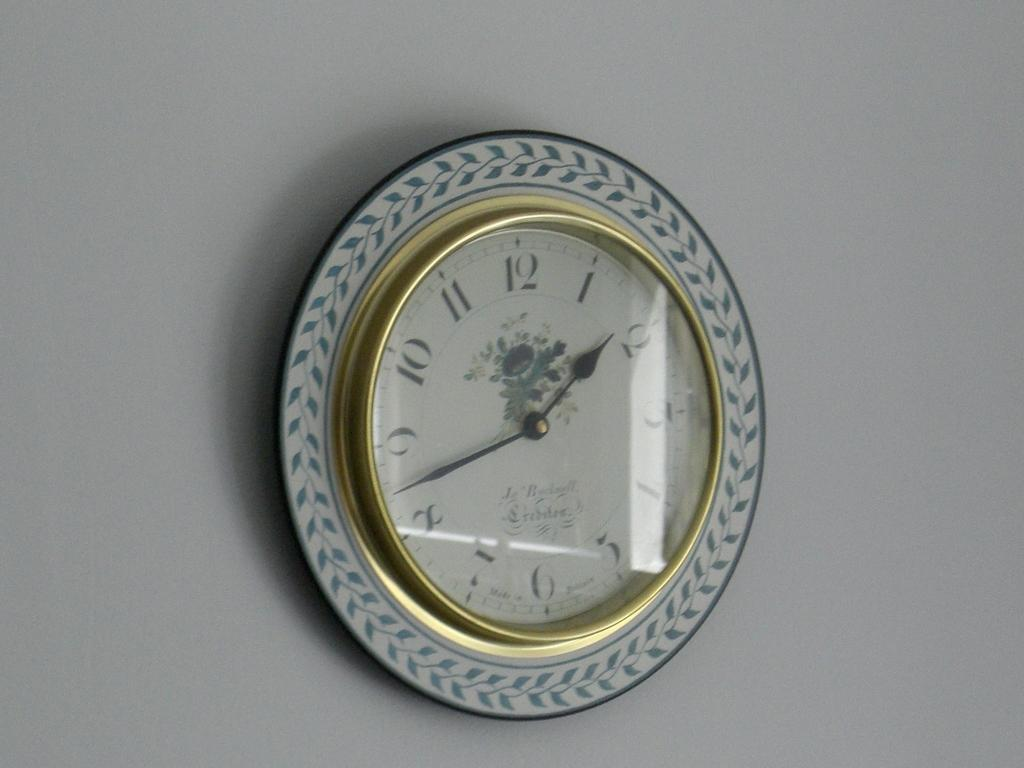<image>
Present a compact description of the photo's key features. A clock with flowers on it is hanging on a white wall and shows that it is almost 1:45. 